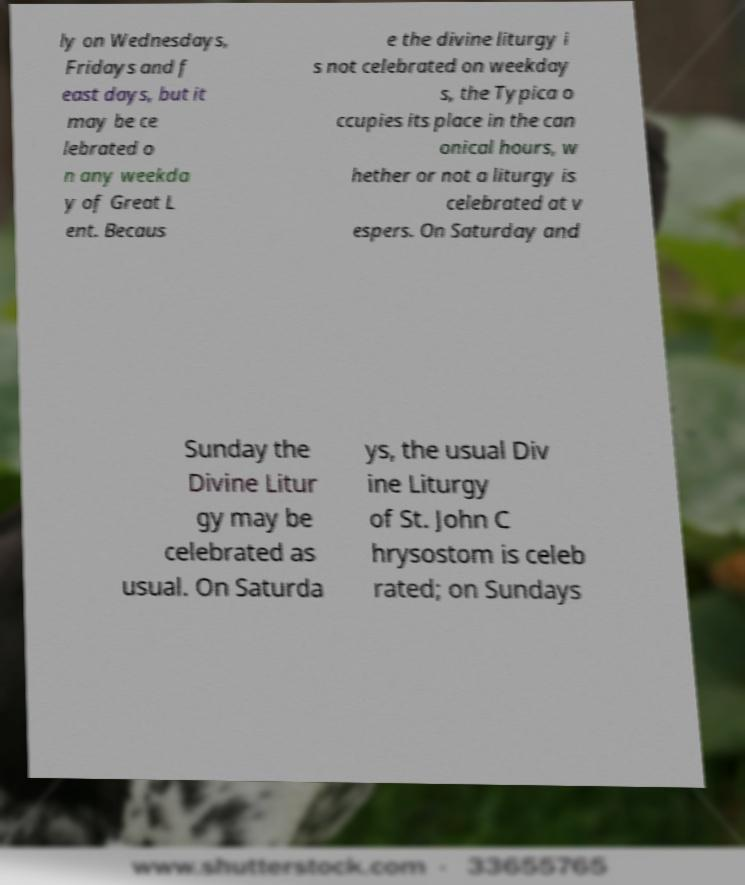What messages or text are displayed in this image? I need them in a readable, typed format. ly on Wednesdays, Fridays and f east days, but it may be ce lebrated o n any weekda y of Great L ent. Becaus e the divine liturgy i s not celebrated on weekday s, the Typica o ccupies its place in the can onical hours, w hether or not a liturgy is celebrated at v espers. On Saturday and Sunday the Divine Litur gy may be celebrated as usual. On Saturda ys, the usual Div ine Liturgy of St. John C hrysostom is celeb rated; on Sundays 